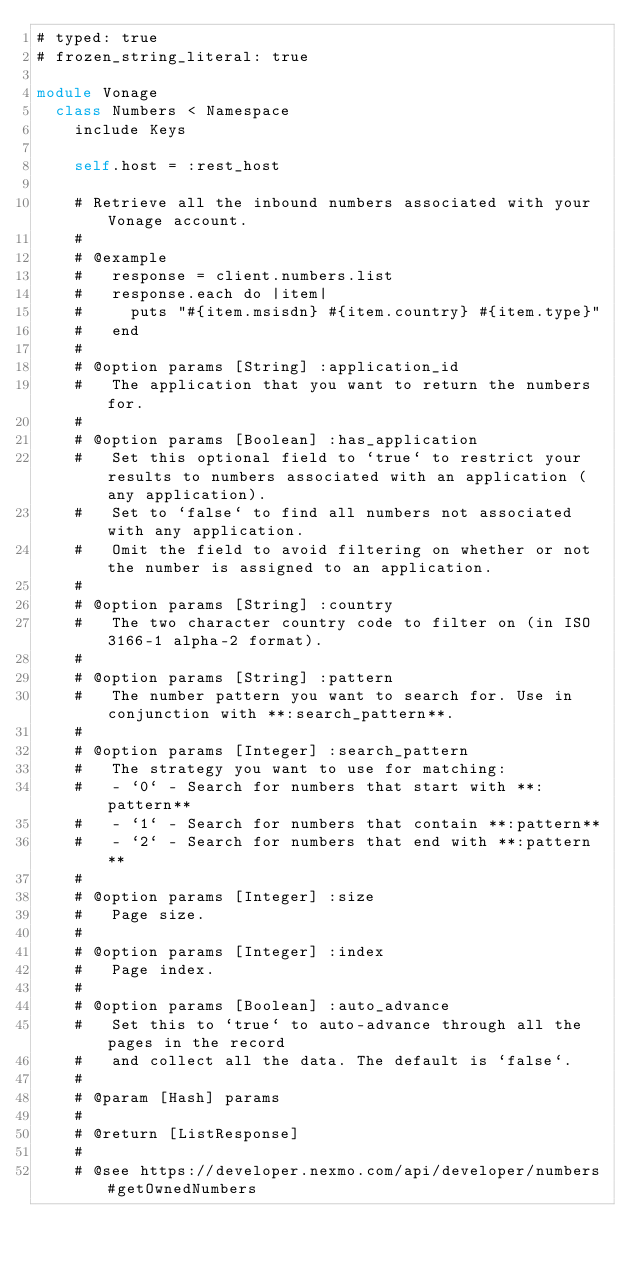<code> <loc_0><loc_0><loc_500><loc_500><_Ruby_># typed: true
# frozen_string_literal: true

module Vonage
  class Numbers < Namespace
    include Keys

    self.host = :rest_host

    # Retrieve all the inbound numbers associated with your Vonage account.
    #
    # @example
    #   response = client.numbers.list
    #   response.each do |item|
    #     puts "#{item.msisdn} #{item.country} #{item.type}"
    #   end
    #
    # @option params [String] :application_id
    #   The application that you want to return the numbers for.
    #
    # @option params [Boolean] :has_application
    #   Set this optional field to `true` to restrict your results to numbers associated with an application (any application).
    #   Set to `false` to find all numbers not associated with any application.
    #   Omit the field to avoid filtering on whether or not the number is assigned to an application.
    #
    # @option params [String] :country
    #   The two character country code to filter on (in ISO 3166-1 alpha-2 format).
    #
    # @option params [String] :pattern
    #   The number pattern you want to search for. Use in conjunction with **:search_pattern**.
    #
    # @option params [Integer] :search_pattern
    #   The strategy you want to use for matching:
    #   - `0` - Search for numbers that start with **:pattern**
    #   - `1` - Search for numbers that contain **:pattern**
    #   - `2` - Search for numbers that end with **:pattern**
    #
    # @option params [Integer] :size
    #   Page size.
    #
    # @option params [Integer] :index
    #   Page index.
    # 
    # @option params [Boolean] :auto_advance
    #   Set this to `true` to auto-advance through all the pages in the record
    #   and collect all the data. The default is `false`.
    # 
    # @param [Hash] params
    #
    # @return [ListResponse]
    #
    # @see https://developer.nexmo.com/api/developer/numbers#getOwnedNumbers</code> 